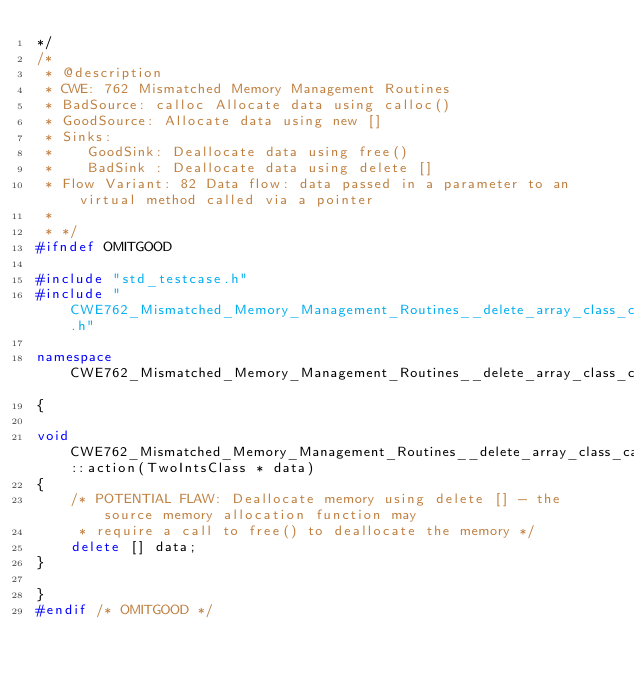Convert code to text. <code><loc_0><loc_0><loc_500><loc_500><_C++_>*/
/*
 * @description
 * CWE: 762 Mismatched Memory Management Routines
 * BadSource: calloc Allocate data using calloc()
 * GoodSource: Allocate data using new []
 * Sinks:
 *    GoodSink: Deallocate data using free()
 *    BadSink : Deallocate data using delete []
 * Flow Variant: 82 Data flow: data passed in a parameter to an virtual method called via a pointer
 *
 * */
#ifndef OMITGOOD

#include "std_testcase.h"
#include "CWE762_Mismatched_Memory_Management_Routines__delete_array_class_calloc_82.h"

namespace CWE762_Mismatched_Memory_Management_Routines__delete_array_class_calloc_82
{

void CWE762_Mismatched_Memory_Management_Routines__delete_array_class_calloc_82_goodG2B::action(TwoIntsClass * data)
{
    /* POTENTIAL FLAW: Deallocate memory using delete [] - the source memory allocation function may
     * require a call to free() to deallocate the memory */
    delete [] data;
}

}
#endif /* OMITGOOD */
</code> 